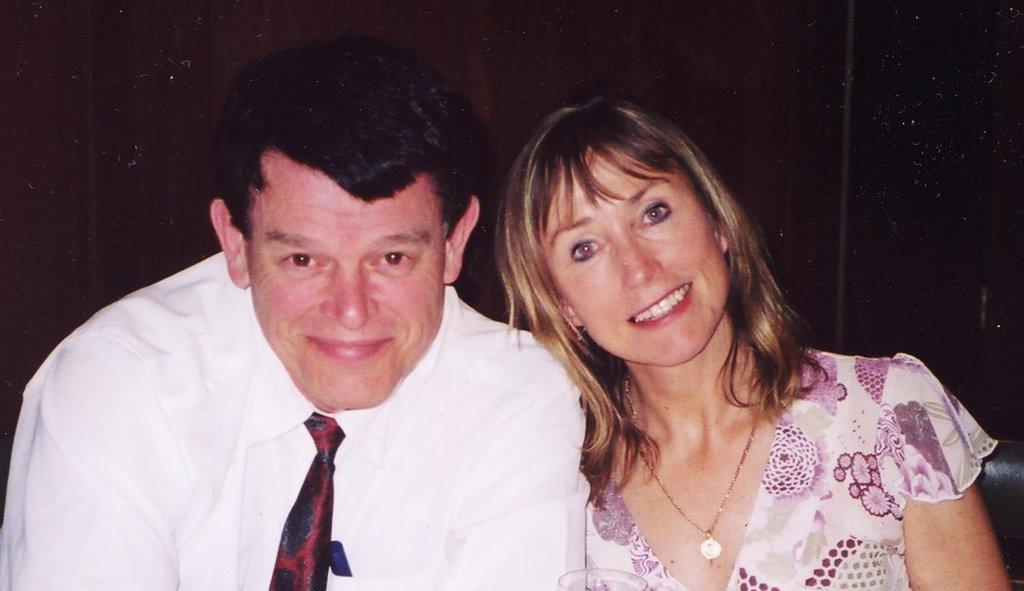Describe this image in one or two sentences. In this image the background is dark. In the middle of the image a man and a woman are sitting on the couch with smiling faces. 